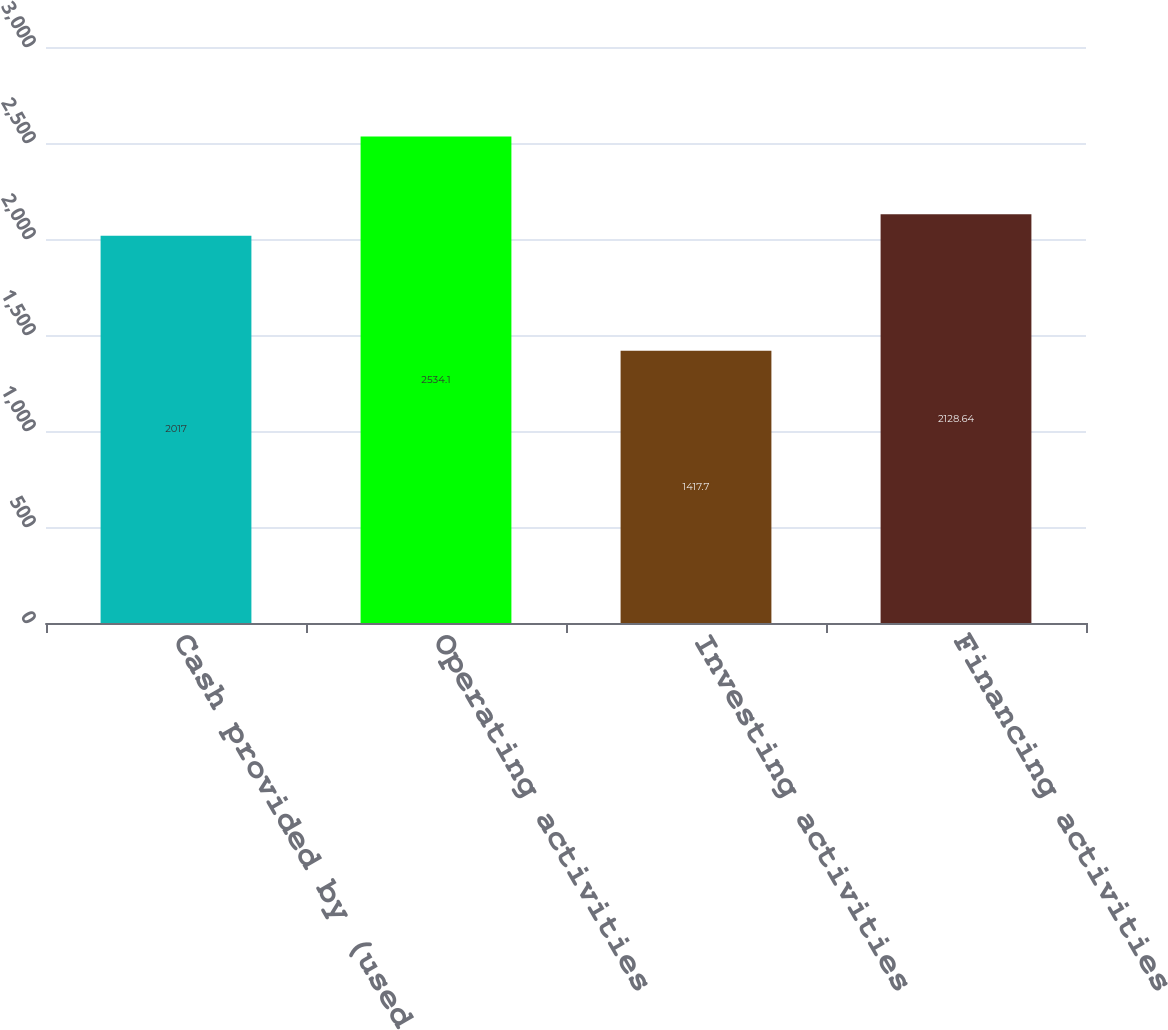<chart> <loc_0><loc_0><loc_500><loc_500><bar_chart><fcel>Cash provided by (used for)<fcel>Operating activities<fcel>Investing activities<fcel>Financing activities<nl><fcel>2017<fcel>2534.1<fcel>1417.7<fcel>2128.64<nl></chart> 